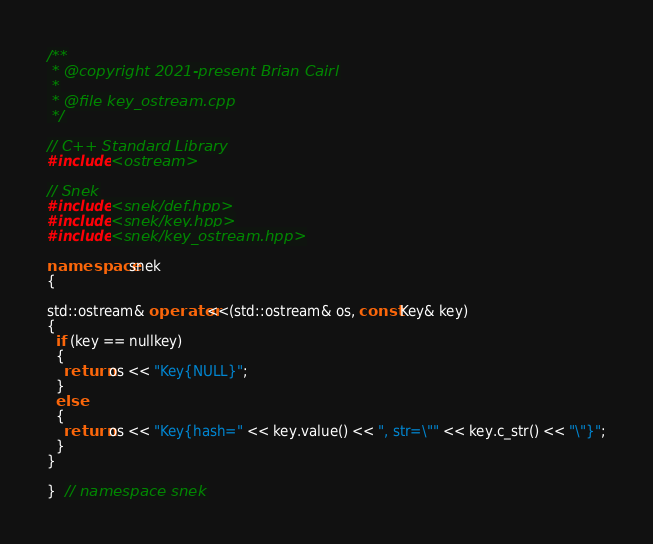Convert code to text. <code><loc_0><loc_0><loc_500><loc_500><_C++_>/**
 * @copyright 2021-present Brian Cairl
 *
 * @file key_ostream.cpp
 */

// C++ Standard Library
#include <ostream>

// Snek
#include <snek/def.hpp>
#include <snek/key.hpp>
#include <snek/key_ostream.hpp>

namespace snek
{

std::ostream& operator<<(std::ostream& os, const Key& key)
{
  if (key == nullkey)
  {
    return os << "Key{NULL}";
  }
  else
  {
    return os << "Key{hash=" << key.value() << ", str=\"" << key.c_str() << "\"}";
  }
}

}  // namespace snek
</code> 